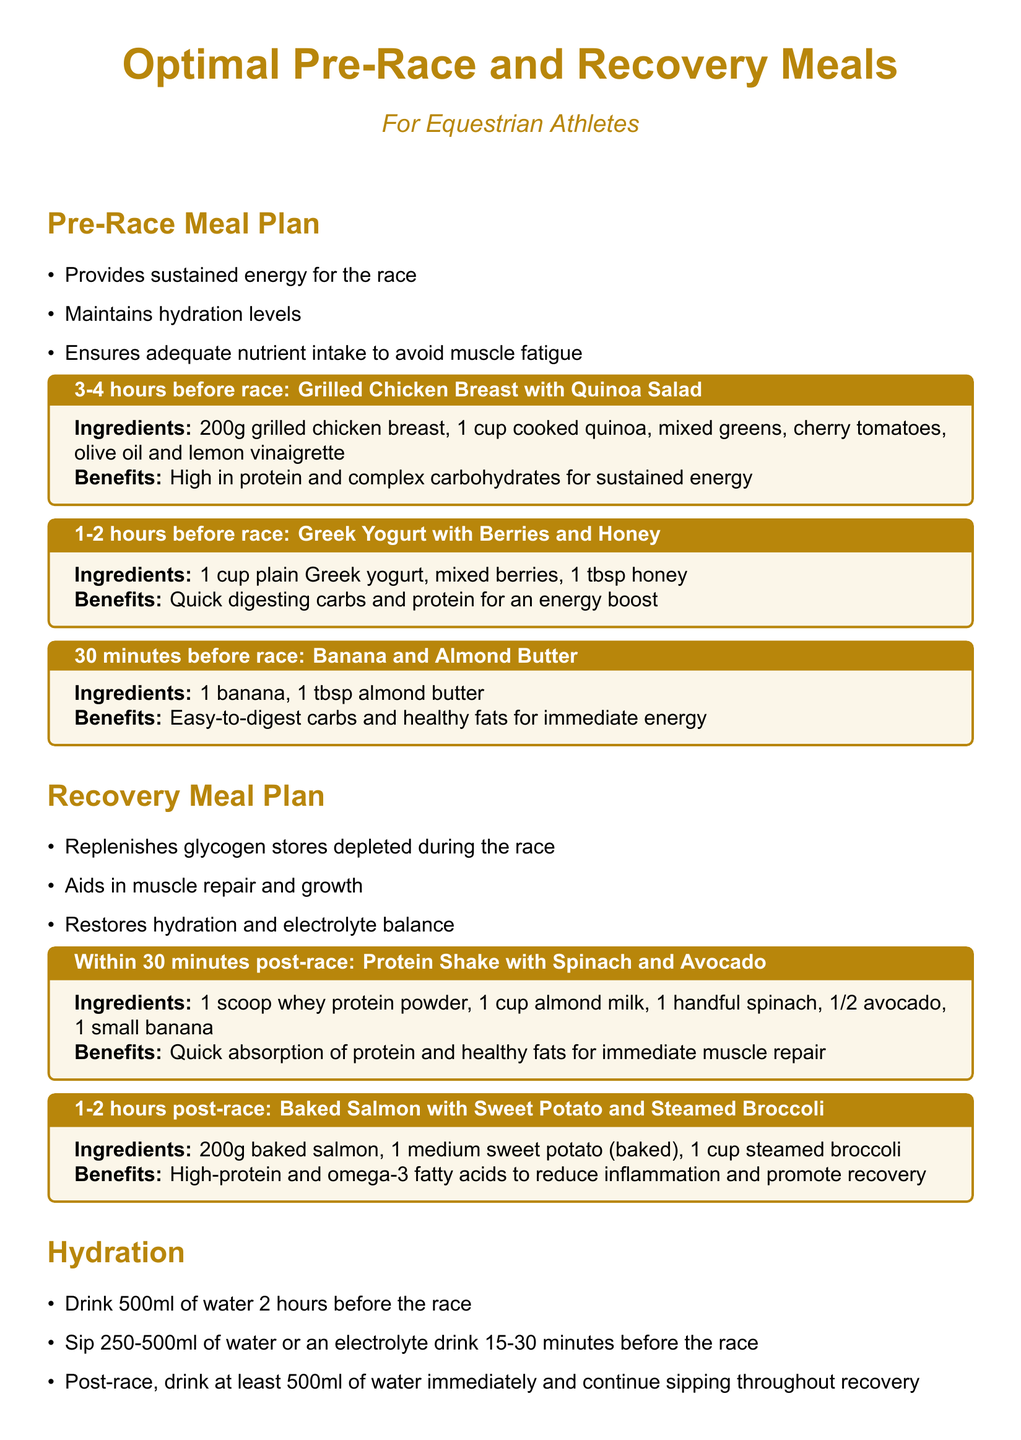What is the main focus of the Pre-Race Meal Plan? The Pre-Race Meal Plan focuses on providing sustained energy, maintaining hydration levels, and ensuring adequate nutrient intake to avoid muscle fatigue.
Answer: Sustained energy What ingredient is in the meal for 30 minutes before the race? The meal for 30 minutes before the race includes a banana and almond butter.
Answer: Banana and almond butter How much water should be consumed two hours before the race? The document specifies that 500ml of water should be consumed two hours before the race.
Answer: 500ml What is the primary benefit of the protein shake consumed post-race? The primary benefit of the protein shake is quick absorption of protein and healthy fats for immediate muscle repair.
Answer: Immediate muscle repair How long should an athlete wait after the race to consume baked salmon? The athlete should wait 1-2 hours post-race to consume baked salmon.
Answer: 1-2 hours What type of protein is recommended in the recovery meal? The recovery meal recommends whey protein powder.
Answer: Whey protein powder What is a low-digesting carbohydrate option for the pre-race meal? Quick digesting carbs are provided in the Greek yogurt with berries and honey meal.
Answer: Greek yogurt with berries and honey What is the recommended hydration immediately post-race? The document recommends drinking at least 500ml of water immediately post-race.
Answer: 500ml 